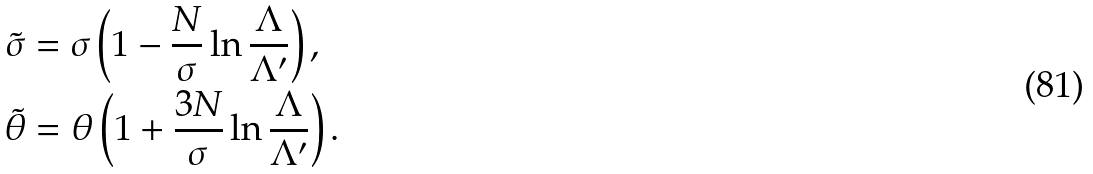Convert formula to latex. <formula><loc_0><loc_0><loc_500><loc_500>\tilde { \sigma } & = \sigma \left ( 1 - \frac { N } { \sigma } \ln \frac { \Lambda } { \Lambda ^ { \prime } } \right ) , \\ \tilde { \theta } & = \theta \left ( 1 + \frac { 3 N } { \sigma } \ln \frac { \Lambda } { \Lambda ^ { \prime } } \right ) .</formula> 